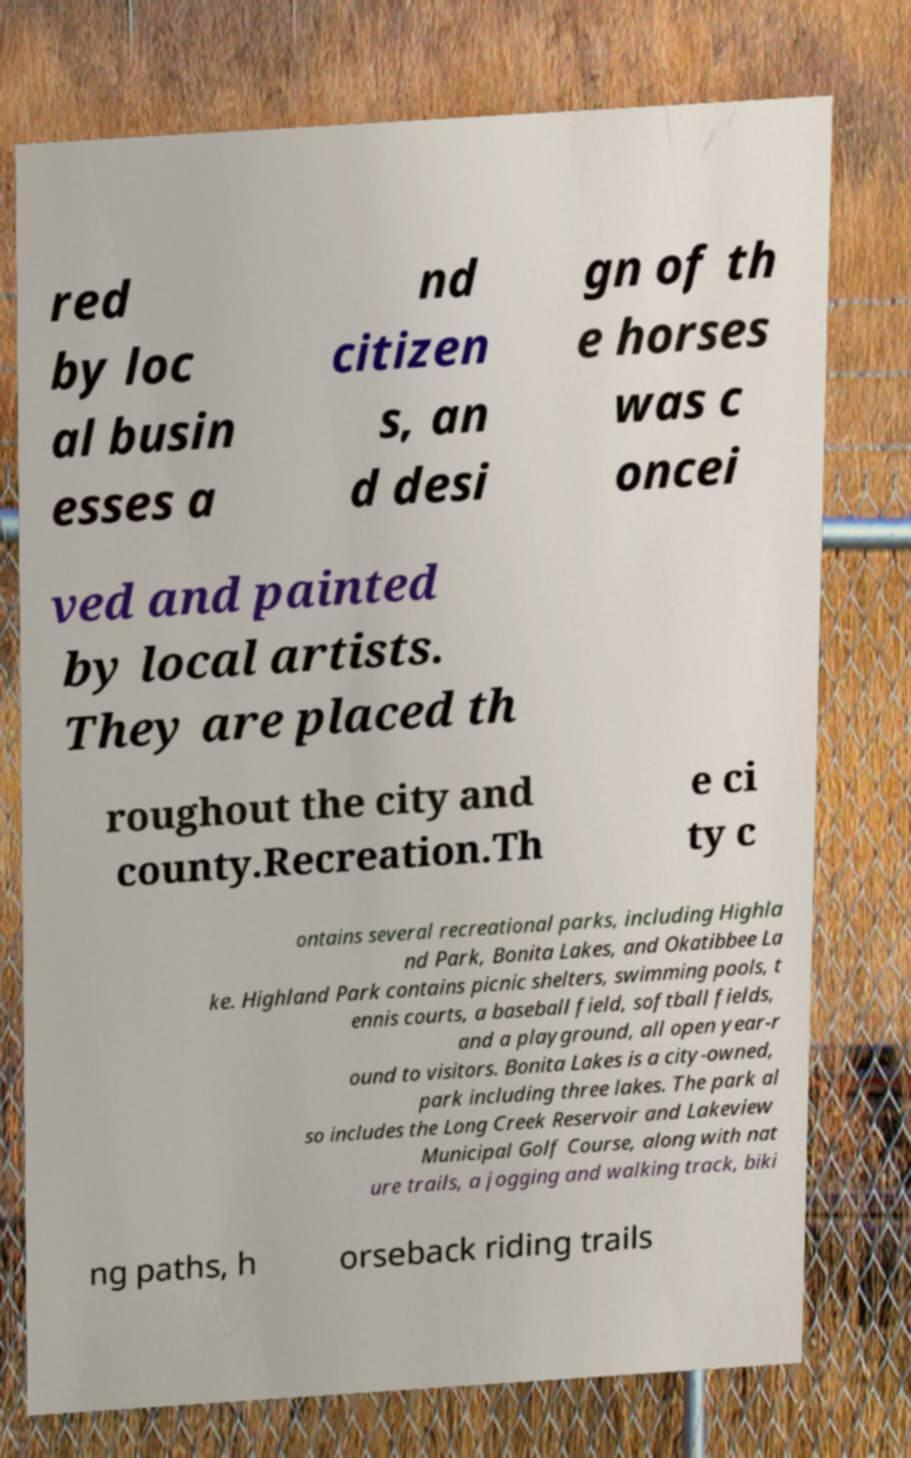Please identify and transcribe the text found in this image. red by loc al busin esses a nd citizen s, an d desi gn of th e horses was c oncei ved and painted by local artists. They are placed th roughout the city and county.Recreation.Th e ci ty c ontains several recreational parks, including Highla nd Park, Bonita Lakes, and Okatibbee La ke. Highland Park contains picnic shelters, swimming pools, t ennis courts, a baseball field, softball fields, and a playground, all open year-r ound to visitors. Bonita Lakes is a city-owned, park including three lakes. The park al so includes the Long Creek Reservoir and Lakeview Municipal Golf Course, along with nat ure trails, a jogging and walking track, biki ng paths, h orseback riding trails 